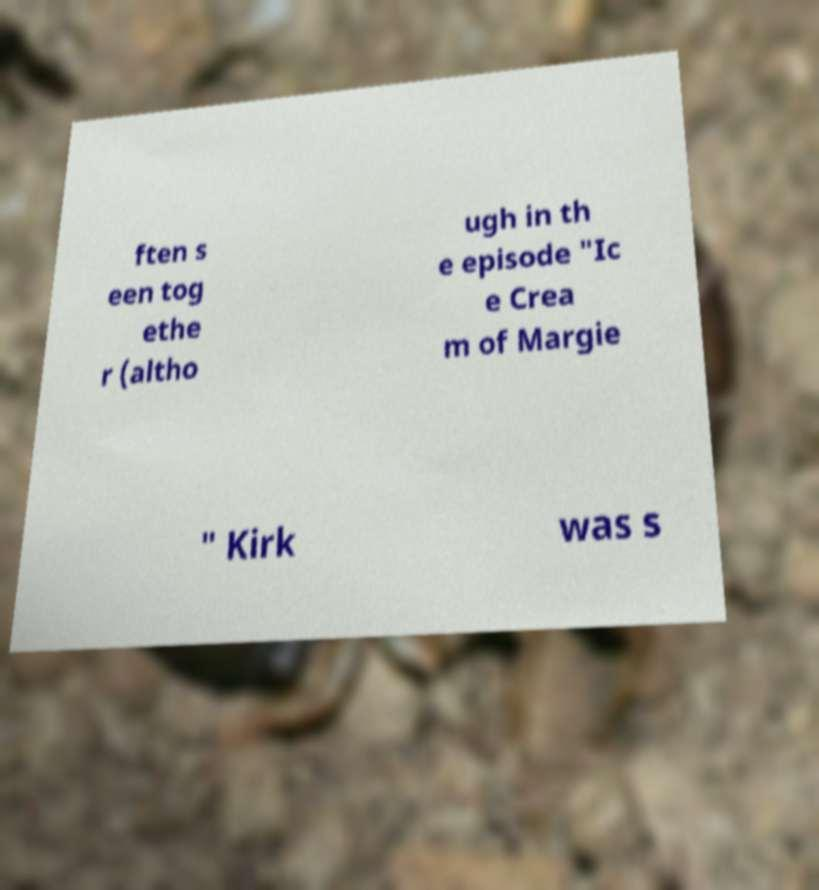Can you read and provide the text displayed in the image?This photo seems to have some interesting text. Can you extract and type it out for me? ften s een tog ethe r (altho ugh in th e episode "Ic e Crea m of Margie " Kirk was s 